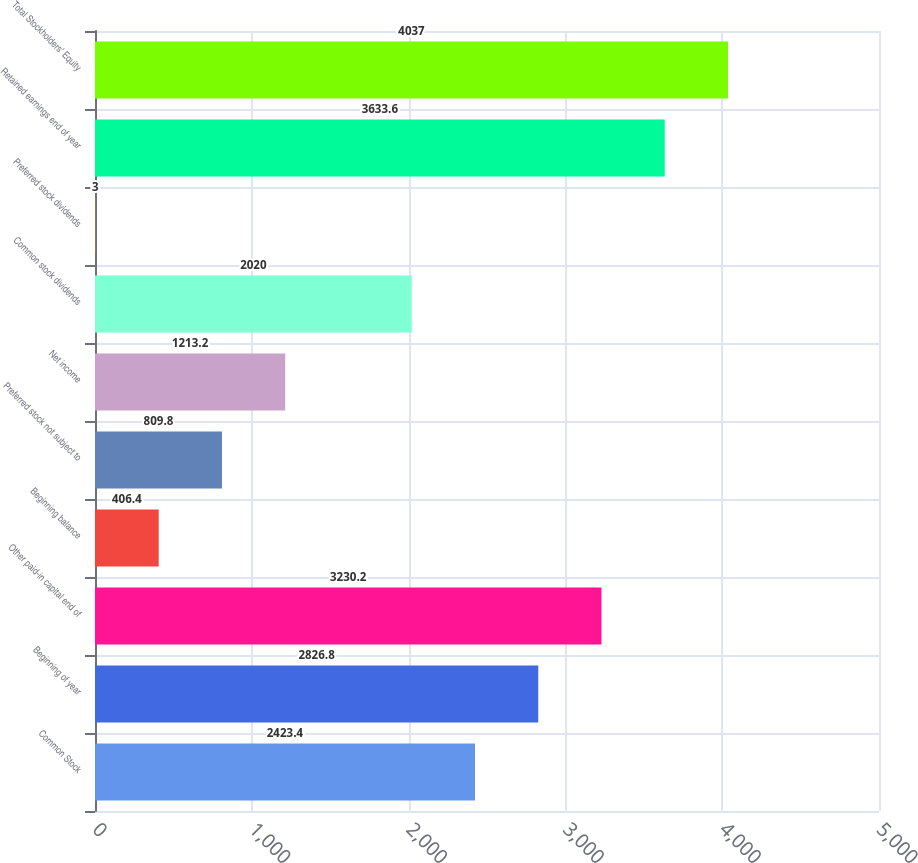<chart> <loc_0><loc_0><loc_500><loc_500><bar_chart><fcel>Common Stock<fcel>Beginning of year<fcel>Other paid-in capital end of<fcel>Beginning balance<fcel>Preferred stock not subject to<fcel>Net income<fcel>Common stock dividends<fcel>Preferred stock dividends<fcel>Retained earnings end of year<fcel>Total Stockholders' Equity<nl><fcel>2423.4<fcel>2826.8<fcel>3230.2<fcel>406.4<fcel>809.8<fcel>1213.2<fcel>2020<fcel>3<fcel>3633.6<fcel>4037<nl></chart> 